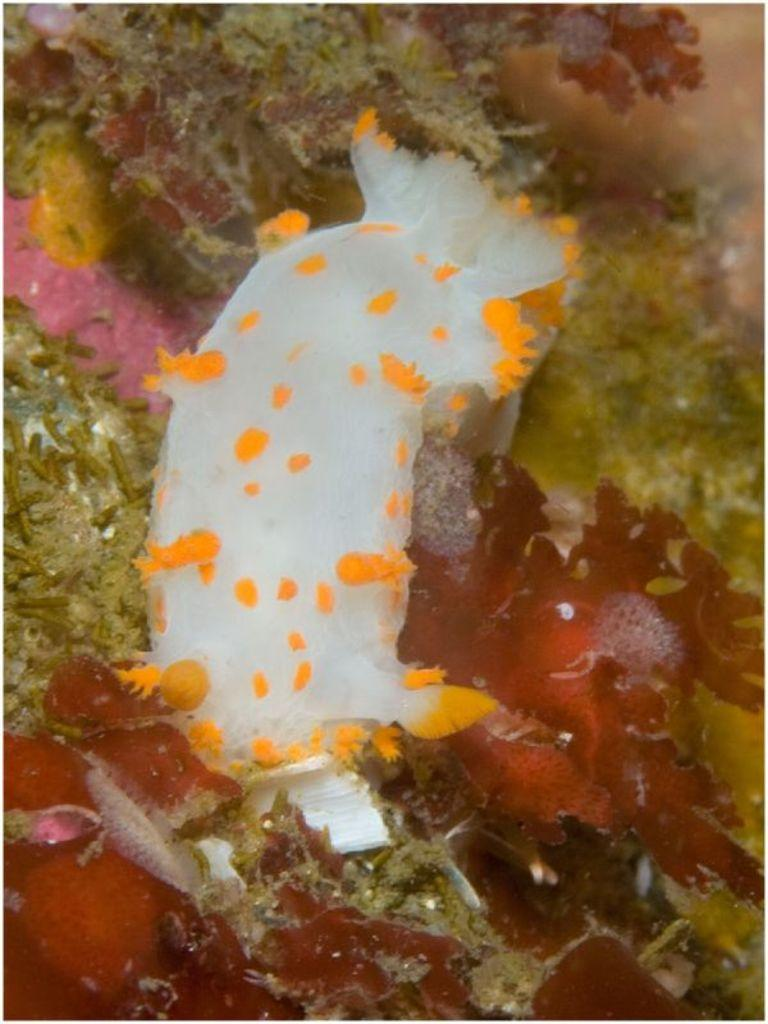What type of animals can be seen in the image? There are fishes in the water in the image. What else can be seen in the image besides the fishes? There are plants visible in the image. Can you describe any other objects or features in the image? There are other unspecified objects in the image. What type of basin is holding the plants in the image? There is no basin present in the image; the plants are in the water with the fishes. What type of plant can be seen flying in the air in the image? There are no plants flying in the air in the image; all plants are in the water with the fishes. 